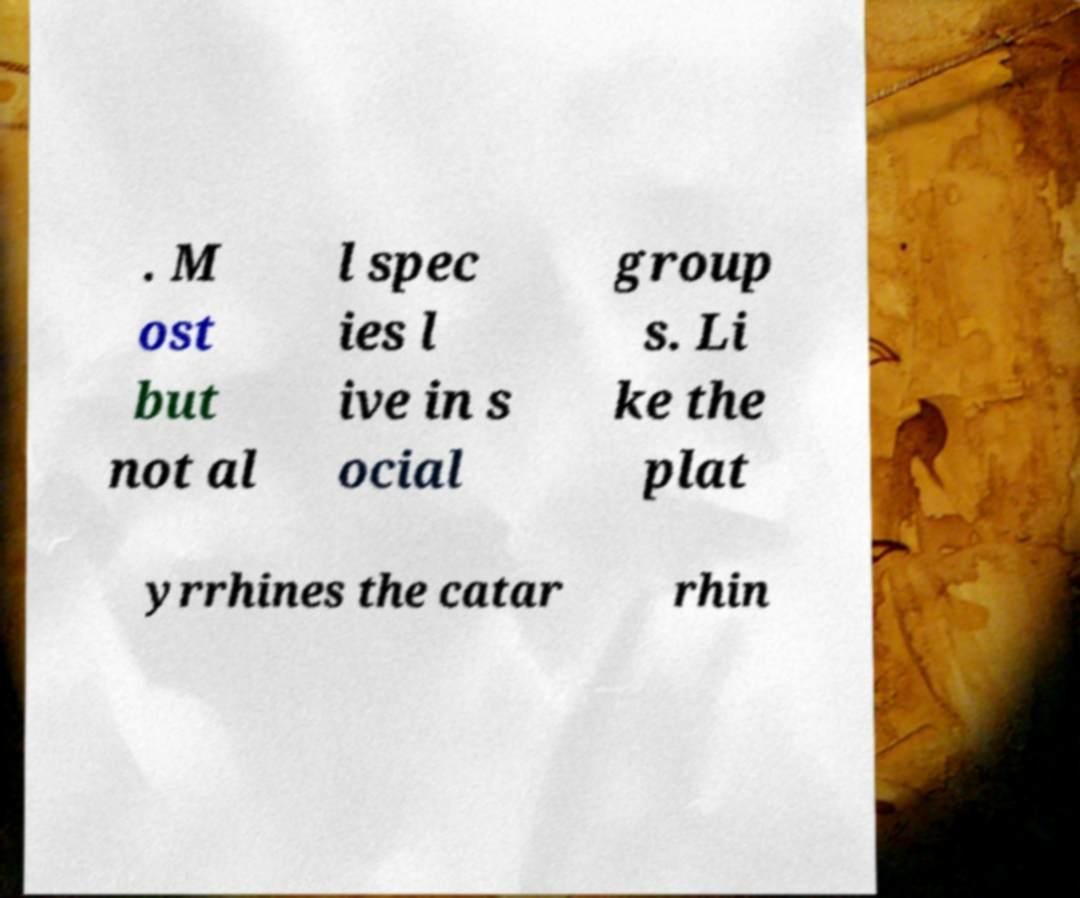There's text embedded in this image that I need extracted. Can you transcribe it verbatim? . M ost but not al l spec ies l ive in s ocial group s. Li ke the plat yrrhines the catar rhin 